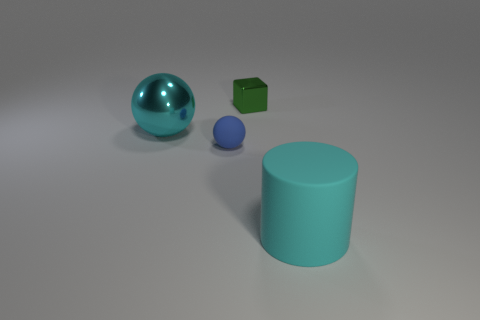Do the big rubber object and the large metal thing have the same color?
Your answer should be very brief. Yes. Do the large thing that is behind the large matte thing and the big rubber object have the same color?
Your answer should be compact. Yes. The thing that is both on the left side of the green object and in front of the cyan metallic sphere is what color?
Offer a very short reply. Blue. What is the shape of the other thing that is the same color as the big rubber thing?
Give a very brief answer. Sphere. How big is the cyan thing that is behind the big cyan object that is right of the small blue ball?
Offer a terse response. Large. What number of cylinders are either tiny yellow matte things or tiny green metal things?
Your answer should be very brief. 0. What color is the metallic thing that is the same size as the cylinder?
Offer a terse response. Cyan. What is the shape of the metal thing on the left side of the tiny thing left of the small metal block?
Give a very brief answer. Sphere. Does the cyan thing on the right side of the block have the same size as the tiny cube?
Give a very brief answer. No. How many other objects are the same material as the green cube?
Your response must be concise. 1. 